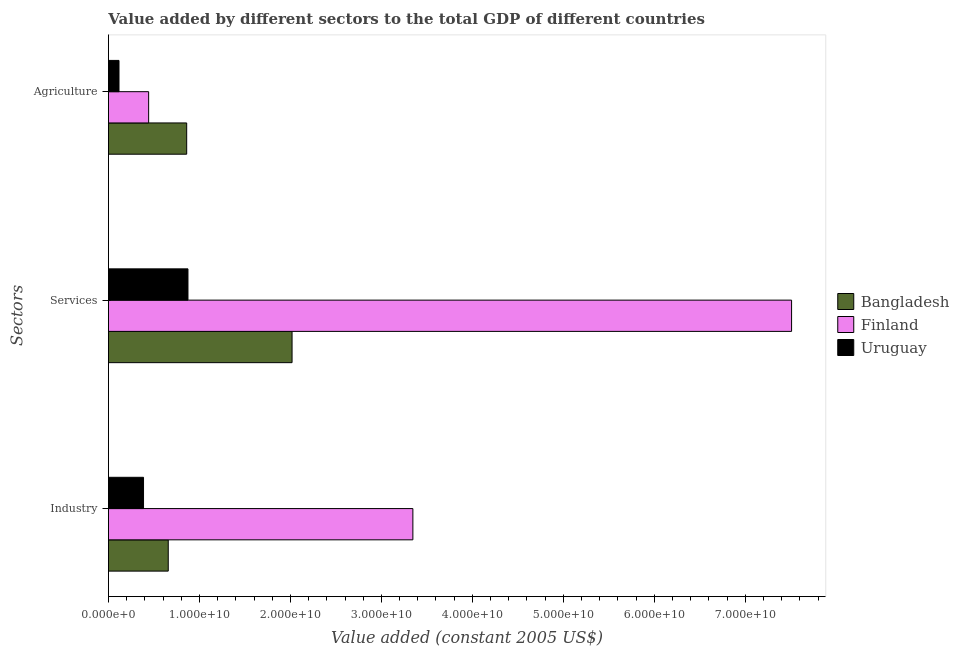How many different coloured bars are there?
Offer a terse response. 3. Are the number of bars per tick equal to the number of legend labels?
Give a very brief answer. Yes. Are the number of bars on each tick of the Y-axis equal?
Provide a short and direct response. Yes. How many bars are there on the 2nd tick from the top?
Give a very brief answer. 3. How many bars are there on the 3rd tick from the bottom?
Offer a very short reply. 3. What is the label of the 2nd group of bars from the top?
Your answer should be compact. Services. What is the value added by industrial sector in Finland?
Offer a terse response. 3.35e+1. Across all countries, what is the maximum value added by industrial sector?
Offer a terse response. 3.35e+1. Across all countries, what is the minimum value added by agricultural sector?
Offer a terse response. 1.16e+09. In which country was the value added by industrial sector maximum?
Give a very brief answer. Finland. In which country was the value added by industrial sector minimum?
Provide a short and direct response. Uruguay. What is the total value added by industrial sector in the graph?
Ensure brevity in your answer.  4.39e+1. What is the difference between the value added by agricultural sector in Uruguay and that in Finland?
Offer a very short reply. -3.26e+09. What is the difference between the value added by agricultural sector in Finland and the value added by industrial sector in Bangladesh?
Your response must be concise. -2.15e+09. What is the average value added by agricultural sector per country?
Offer a terse response. 4.73e+09. What is the difference between the value added by services and value added by industrial sector in Finland?
Your answer should be very brief. 4.16e+1. In how many countries, is the value added by services greater than 46000000000 US$?
Provide a short and direct response. 1. What is the ratio of the value added by services in Uruguay to that in Finland?
Your answer should be compact. 0.12. What is the difference between the highest and the second highest value added by agricultural sector?
Offer a terse response. 4.18e+09. What is the difference between the highest and the lowest value added by services?
Provide a short and direct response. 6.63e+1. In how many countries, is the value added by industrial sector greater than the average value added by industrial sector taken over all countries?
Your answer should be very brief. 1. Is the sum of the value added by agricultural sector in Bangladesh and Uruguay greater than the maximum value added by services across all countries?
Offer a very short reply. No. What does the 3rd bar from the bottom in Industry represents?
Your answer should be very brief. Uruguay. Is it the case that in every country, the sum of the value added by industrial sector and value added by services is greater than the value added by agricultural sector?
Your answer should be very brief. Yes. What is the difference between two consecutive major ticks on the X-axis?
Offer a very short reply. 1.00e+1. Does the graph contain any zero values?
Offer a very short reply. No. Does the graph contain grids?
Offer a very short reply. No. Where does the legend appear in the graph?
Keep it short and to the point. Center right. How many legend labels are there?
Ensure brevity in your answer.  3. How are the legend labels stacked?
Give a very brief answer. Vertical. What is the title of the graph?
Your response must be concise. Value added by different sectors to the total GDP of different countries. What is the label or title of the X-axis?
Your answer should be very brief. Value added (constant 2005 US$). What is the label or title of the Y-axis?
Your response must be concise. Sectors. What is the Value added (constant 2005 US$) of Bangladesh in Industry?
Your response must be concise. 6.57e+09. What is the Value added (constant 2005 US$) of Finland in Industry?
Ensure brevity in your answer.  3.35e+1. What is the Value added (constant 2005 US$) in Uruguay in Industry?
Provide a succinct answer. 3.86e+09. What is the Value added (constant 2005 US$) of Bangladesh in Services?
Provide a succinct answer. 2.02e+1. What is the Value added (constant 2005 US$) of Finland in Services?
Provide a succinct answer. 7.51e+1. What is the Value added (constant 2005 US$) of Uruguay in Services?
Provide a short and direct response. 8.74e+09. What is the Value added (constant 2005 US$) of Bangladesh in Agriculture?
Ensure brevity in your answer.  8.60e+09. What is the Value added (constant 2005 US$) of Finland in Agriculture?
Your answer should be compact. 4.42e+09. What is the Value added (constant 2005 US$) of Uruguay in Agriculture?
Offer a terse response. 1.16e+09. Across all Sectors, what is the maximum Value added (constant 2005 US$) of Bangladesh?
Ensure brevity in your answer.  2.02e+1. Across all Sectors, what is the maximum Value added (constant 2005 US$) of Finland?
Provide a short and direct response. 7.51e+1. Across all Sectors, what is the maximum Value added (constant 2005 US$) in Uruguay?
Provide a succinct answer. 8.74e+09. Across all Sectors, what is the minimum Value added (constant 2005 US$) of Bangladesh?
Ensure brevity in your answer.  6.57e+09. Across all Sectors, what is the minimum Value added (constant 2005 US$) of Finland?
Provide a succinct answer. 4.42e+09. Across all Sectors, what is the minimum Value added (constant 2005 US$) of Uruguay?
Your response must be concise. 1.16e+09. What is the total Value added (constant 2005 US$) of Bangladesh in the graph?
Keep it short and to the point. 3.54e+1. What is the total Value added (constant 2005 US$) of Finland in the graph?
Offer a very short reply. 1.13e+11. What is the total Value added (constant 2005 US$) in Uruguay in the graph?
Make the answer very short. 1.38e+1. What is the difference between the Value added (constant 2005 US$) in Bangladesh in Industry and that in Services?
Keep it short and to the point. -1.36e+1. What is the difference between the Value added (constant 2005 US$) of Finland in Industry and that in Services?
Give a very brief answer. -4.16e+1. What is the difference between the Value added (constant 2005 US$) in Uruguay in Industry and that in Services?
Your answer should be very brief. -4.88e+09. What is the difference between the Value added (constant 2005 US$) of Bangladesh in Industry and that in Agriculture?
Provide a short and direct response. -2.03e+09. What is the difference between the Value added (constant 2005 US$) in Finland in Industry and that in Agriculture?
Keep it short and to the point. 2.90e+1. What is the difference between the Value added (constant 2005 US$) of Uruguay in Industry and that in Agriculture?
Offer a very short reply. 2.69e+09. What is the difference between the Value added (constant 2005 US$) of Bangladesh in Services and that in Agriculture?
Your answer should be very brief. 1.16e+1. What is the difference between the Value added (constant 2005 US$) in Finland in Services and that in Agriculture?
Keep it short and to the point. 7.07e+1. What is the difference between the Value added (constant 2005 US$) of Uruguay in Services and that in Agriculture?
Ensure brevity in your answer.  7.58e+09. What is the difference between the Value added (constant 2005 US$) in Bangladesh in Industry and the Value added (constant 2005 US$) in Finland in Services?
Your response must be concise. -6.85e+1. What is the difference between the Value added (constant 2005 US$) of Bangladesh in Industry and the Value added (constant 2005 US$) of Uruguay in Services?
Give a very brief answer. -2.17e+09. What is the difference between the Value added (constant 2005 US$) of Finland in Industry and the Value added (constant 2005 US$) of Uruguay in Services?
Ensure brevity in your answer.  2.47e+1. What is the difference between the Value added (constant 2005 US$) in Bangladesh in Industry and the Value added (constant 2005 US$) in Finland in Agriculture?
Your response must be concise. 2.15e+09. What is the difference between the Value added (constant 2005 US$) in Bangladesh in Industry and the Value added (constant 2005 US$) in Uruguay in Agriculture?
Your answer should be compact. 5.41e+09. What is the difference between the Value added (constant 2005 US$) of Finland in Industry and the Value added (constant 2005 US$) of Uruguay in Agriculture?
Your response must be concise. 3.23e+1. What is the difference between the Value added (constant 2005 US$) of Bangladesh in Services and the Value added (constant 2005 US$) of Finland in Agriculture?
Your answer should be compact. 1.58e+1. What is the difference between the Value added (constant 2005 US$) in Bangladesh in Services and the Value added (constant 2005 US$) in Uruguay in Agriculture?
Keep it short and to the point. 1.90e+1. What is the difference between the Value added (constant 2005 US$) of Finland in Services and the Value added (constant 2005 US$) of Uruguay in Agriculture?
Offer a terse response. 7.39e+1. What is the average Value added (constant 2005 US$) in Bangladesh per Sectors?
Your answer should be compact. 1.18e+1. What is the average Value added (constant 2005 US$) in Finland per Sectors?
Provide a short and direct response. 3.77e+1. What is the average Value added (constant 2005 US$) in Uruguay per Sectors?
Provide a short and direct response. 4.59e+09. What is the difference between the Value added (constant 2005 US$) in Bangladesh and Value added (constant 2005 US$) in Finland in Industry?
Offer a terse response. -2.69e+1. What is the difference between the Value added (constant 2005 US$) of Bangladesh and Value added (constant 2005 US$) of Uruguay in Industry?
Provide a short and direct response. 2.72e+09. What is the difference between the Value added (constant 2005 US$) in Finland and Value added (constant 2005 US$) in Uruguay in Industry?
Your answer should be very brief. 2.96e+1. What is the difference between the Value added (constant 2005 US$) of Bangladesh and Value added (constant 2005 US$) of Finland in Services?
Offer a terse response. -5.49e+1. What is the difference between the Value added (constant 2005 US$) of Bangladesh and Value added (constant 2005 US$) of Uruguay in Services?
Your response must be concise. 1.14e+1. What is the difference between the Value added (constant 2005 US$) of Finland and Value added (constant 2005 US$) of Uruguay in Services?
Keep it short and to the point. 6.63e+1. What is the difference between the Value added (constant 2005 US$) in Bangladesh and Value added (constant 2005 US$) in Finland in Agriculture?
Make the answer very short. 4.18e+09. What is the difference between the Value added (constant 2005 US$) of Bangladesh and Value added (constant 2005 US$) of Uruguay in Agriculture?
Provide a short and direct response. 7.44e+09. What is the difference between the Value added (constant 2005 US$) of Finland and Value added (constant 2005 US$) of Uruguay in Agriculture?
Your answer should be compact. 3.26e+09. What is the ratio of the Value added (constant 2005 US$) in Bangladesh in Industry to that in Services?
Your response must be concise. 0.33. What is the ratio of the Value added (constant 2005 US$) of Finland in Industry to that in Services?
Keep it short and to the point. 0.45. What is the ratio of the Value added (constant 2005 US$) in Uruguay in Industry to that in Services?
Offer a very short reply. 0.44. What is the ratio of the Value added (constant 2005 US$) of Bangladesh in Industry to that in Agriculture?
Offer a very short reply. 0.76. What is the ratio of the Value added (constant 2005 US$) of Finland in Industry to that in Agriculture?
Give a very brief answer. 7.57. What is the ratio of the Value added (constant 2005 US$) in Uruguay in Industry to that in Agriculture?
Keep it short and to the point. 3.32. What is the ratio of the Value added (constant 2005 US$) in Bangladesh in Services to that in Agriculture?
Provide a short and direct response. 2.35. What is the ratio of the Value added (constant 2005 US$) of Finland in Services to that in Agriculture?
Ensure brevity in your answer.  16.99. What is the ratio of the Value added (constant 2005 US$) of Uruguay in Services to that in Agriculture?
Provide a succinct answer. 7.52. What is the difference between the highest and the second highest Value added (constant 2005 US$) in Bangladesh?
Provide a succinct answer. 1.16e+1. What is the difference between the highest and the second highest Value added (constant 2005 US$) in Finland?
Your answer should be compact. 4.16e+1. What is the difference between the highest and the second highest Value added (constant 2005 US$) of Uruguay?
Offer a terse response. 4.88e+09. What is the difference between the highest and the lowest Value added (constant 2005 US$) in Bangladesh?
Keep it short and to the point. 1.36e+1. What is the difference between the highest and the lowest Value added (constant 2005 US$) in Finland?
Offer a very short reply. 7.07e+1. What is the difference between the highest and the lowest Value added (constant 2005 US$) in Uruguay?
Your answer should be very brief. 7.58e+09. 